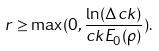<formula> <loc_0><loc_0><loc_500><loc_500>r \geq \max ( 0 , \frac { \ln ( \Delta c k ) } { c k E _ { 0 } ( \rho ) } ) .</formula> 